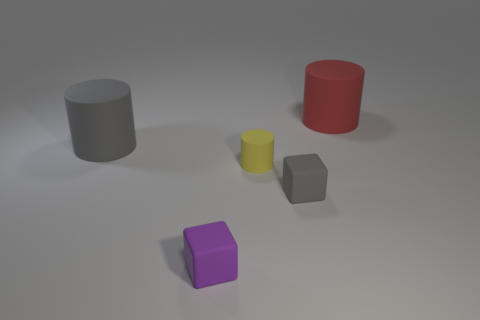There is a large thing to the left of the matte cylinder right of the small gray cube; what is its color?
Your answer should be very brief. Gray. How many cubes are either large yellow objects or large gray matte things?
Offer a terse response. 0. What number of matte objects are behind the tiny purple thing and to the left of the tiny yellow cylinder?
Offer a terse response. 1. There is a large rubber object that is left of the big red cylinder; what is its color?
Offer a very short reply. Gray. What is the size of the purple block that is made of the same material as the red cylinder?
Offer a terse response. Small. There is a matte cube to the left of the gray block; what number of gray matte cylinders are behind it?
Provide a succinct answer. 1. What number of small cylinders are left of the yellow object?
Provide a short and direct response. 0. What color is the small object behind the gray thing on the right side of the large rubber object in front of the red rubber cylinder?
Provide a succinct answer. Yellow. Is the color of the matte block that is on the right side of the purple cube the same as the big matte thing on the right side of the small purple matte object?
Offer a terse response. No. There is a gray rubber object behind the gray thing that is in front of the yellow rubber cylinder; what shape is it?
Provide a succinct answer. Cylinder. 